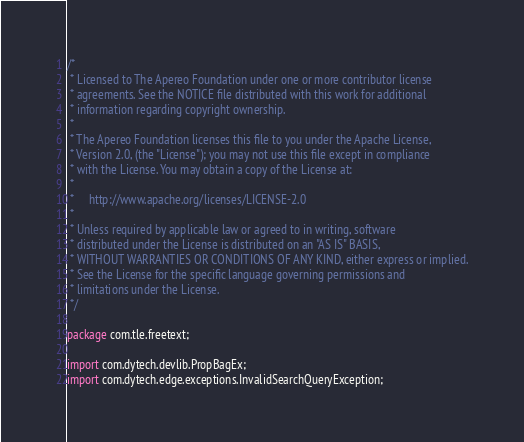Convert code to text. <code><loc_0><loc_0><loc_500><loc_500><_Java_>/*
 * Licensed to The Apereo Foundation under one or more contributor license
 * agreements. See the NOTICE file distributed with this work for additional
 * information regarding copyright ownership.
 *
 * The Apereo Foundation licenses this file to you under the Apache License,
 * Version 2.0, (the "License"); you may not use this file except in compliance
 * with the License. You may obtain a copy of the License at:
 *
 *     http://www.apache.org/licenses/LICENSE-2.0
 *
 * Unless required by applicable law or agreed to in writing, software
 * distributed under the License is distributed on an "AS IS" BASIS,
 * WITHOUT WARRANTIES OR CONDITIONS OF ANY KIND, either express or implied.
 * See the License for the specific language governing permissions and
 * limitations under the License.
 */

package com.tle.freetext;

import com.dytech.devlib.PropBagEx;
import com.dytech.edge.exceptions.InvalidSearchQueryException;</code> 